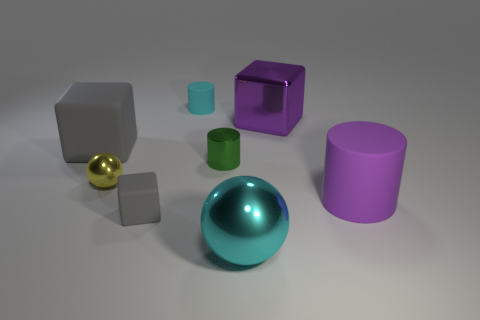Subtract all shiny cylinders. How many cylinders are left? 2 Subtract all red spheres. How many gray cubes are left? 2 Subtract 1 cubes. How many cubes are left? 2 Add 2 small yellow spheres. How many objects exist? 10 Subtract all brown cylinders. Subtract all red spheres. How many cylinders are left? 3 Subtract 1 purple blocks. How many objects are left? 7 Subtract all cylinders. How many objects are left? 5 Subtract all large cyan things. Subtract all tiny green metallic cylinders. How many objects are left? 6 Add 4 small gray matte blocks. How many small gray matte blocks are left? 5 Add 8 matte cylinders. How many matte cylinders exist? 10 